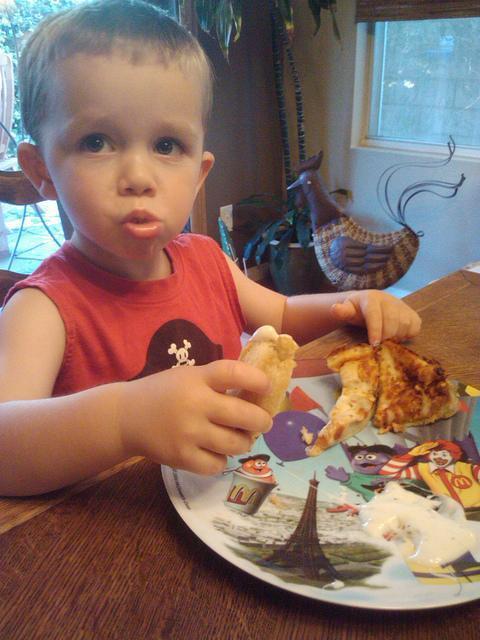How many birds have red on their head?
Give a very brief answer. 0. 